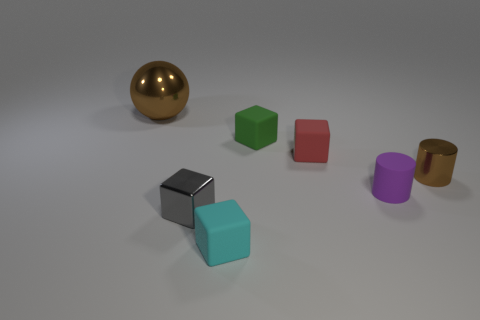There is a large metallic ball; is its color the same as the tiny object that is on the left side of the small cyan matte cube?
Ensure brevity in your answer.  No. What is the shape of the big object?
Your answer should be very brief. Sphere. What is the size of the cylinder that is to the left of the brown metal thing in front of the brown shiny object left of the red rubber object?
Ensure brevity in your answer.  Small. What number of other objects are there of the same shape as the large thing?
Your response must be concise. 0. Does the brown object on the left side of the small green matte block have the same shape as the metal thing that is on the right side of the cyan thing?
Make the answer very short. No. What number of blocks are either small brown things or matte things?
Make the answer very short. 3. What is the material of the object to the left of the metal object in front of the brown object that is right of the small red matte object?
Give a very brief answer. Metal. How many other objects are the same size as the purple matte thing?
Your answer should be compact. 5. What is the size of the cylinder that is the same color as the large metallic object?
Your answer should be very brief. Small. Are there more small brown metallic things that are to the left of the small purple cylinder than green matte blocks?
Your response must be concise. No. 